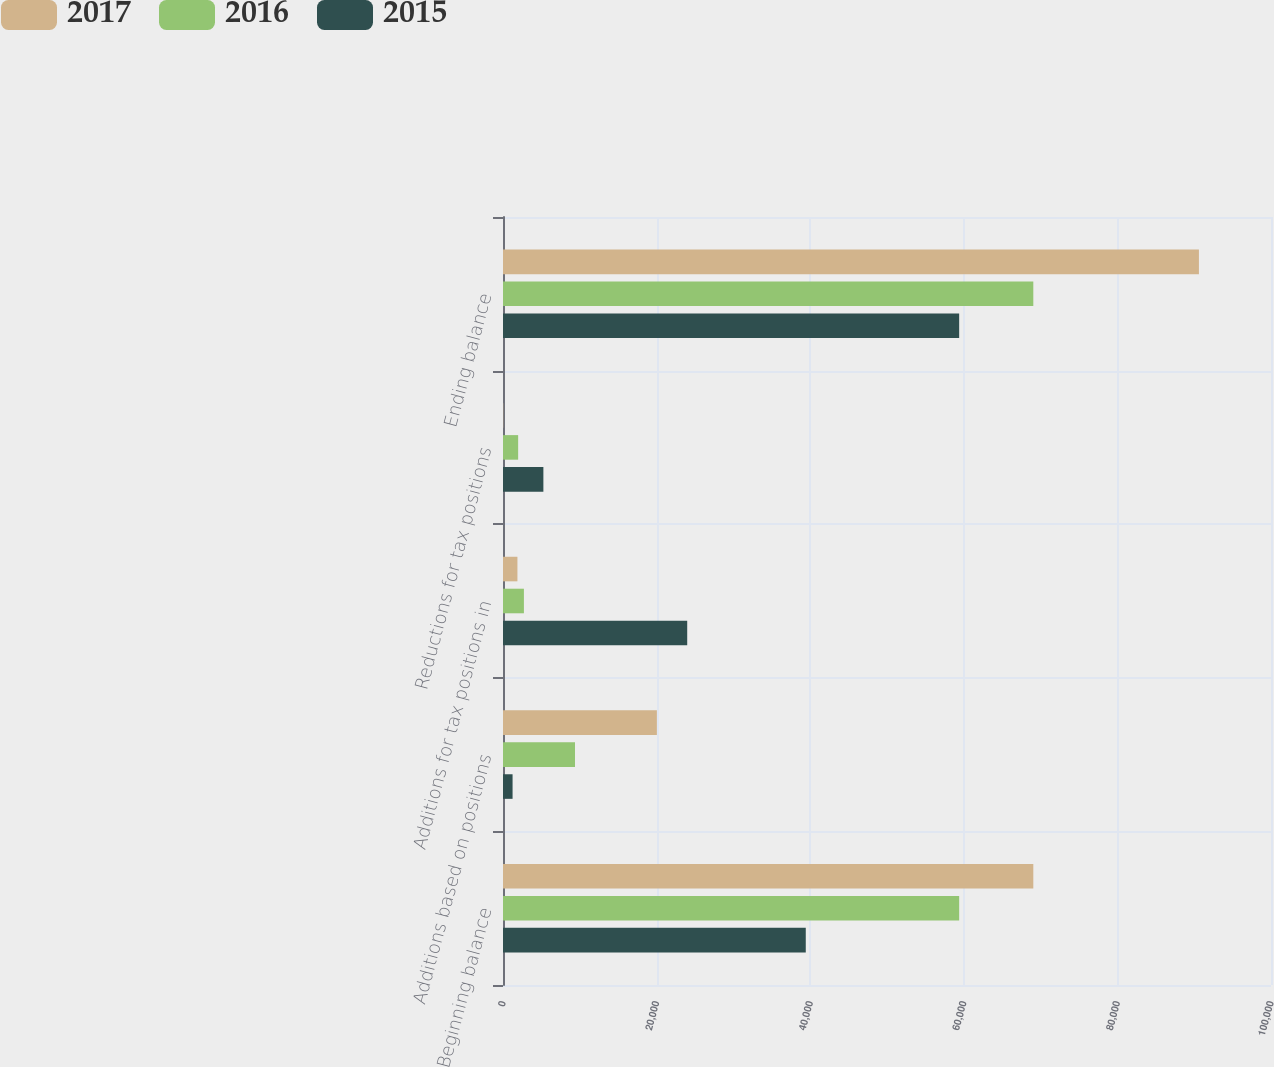Convert chart. <chart><loc_0><loc_0><loc_500><loc_500><stacked_bar_chart><ecel><fcel>Beginning balance<fcel>Additions based on positions<fcel>Additions for tax positions in<fcel>Reductions for tax positions<fcel>Ending balance<nl><fcel>2017<fcel>69052<fcel>20036<fcel>1878<fcel>29<fcel>90615<nl><fcel>2016<fcel>59397<fcel>9374<fcel>2723<fcel>1973<fcel>69052<nl><fcel>2015<fcel>39423<fcel>1246<fcel>23986<fcel>5258<fcel>59397<nl></chart> 